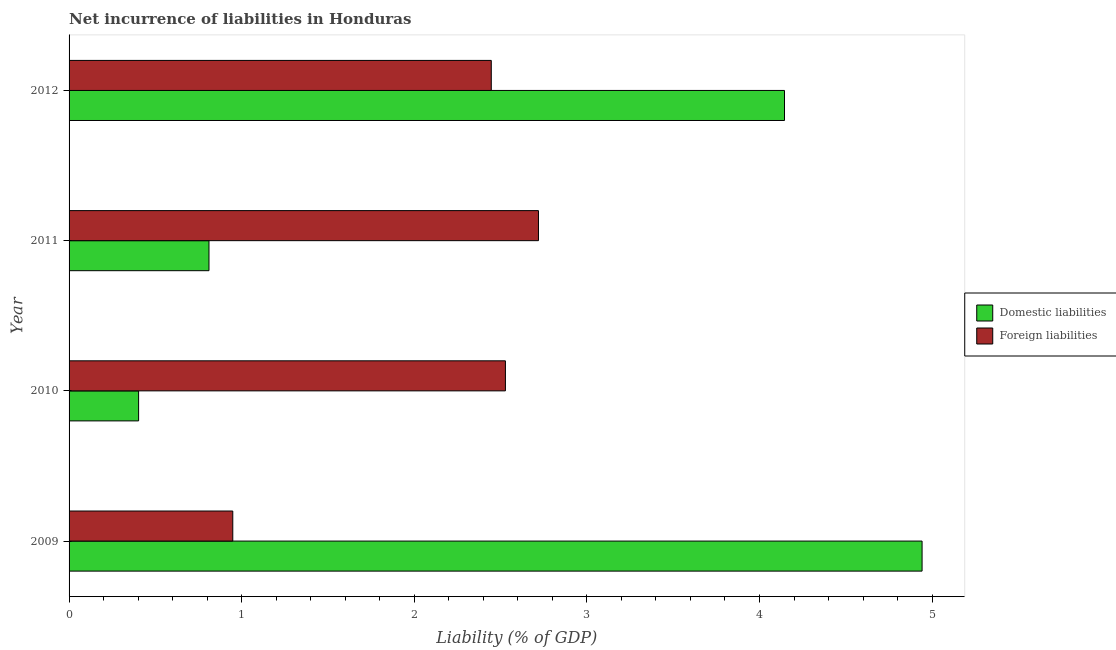How many different coloured bars are there?
Your answer should be very brief. 2. How many groups of bars are there?
Make the answer very short. 4. Are the number of bars per tick equal to the number of legend labels?
Give a very brief answer. Yes. Are the number of bars on each tick of the Y-axis equal?
Keep it short and to the point. Yes. How many bars are there on the 2nd tick from the top?
Your answer should be very brief. 2. How many bars are there on the 1st tick from the bottom?
Your answer should be compact. 2. In how many cases, is the number of bars for a given year not equal to the number of legend labels?
Keep it short and to the point. 0. What is the incurrence of foreign liabilities in 2010?
Provide a succinct answer. 2.53. Across all years, what is the maximum incurrence of foreign liabilities?
Offer a very short reply. 2.72. Across all years, what is the minimum incurrence of domestic liabilities?
Offer a very short reply. 0.4. In which year was the incurrence of domestic liabilities maximum?
Provide a short and direct response. 2009. What is the total incurrence of domestic liabilities in the graph?
Keep it short and to the point. 10.3. What is the difference between the incurrence of foreign liabilities in 2009 and that in 2011?
Make the answer very short. -1.77. What is the difference between the incurrence of foreign liabilities in 2009 and the incurrence of domestic liabilities in 2010?
Your answer should be very brief. 0.55. What is the average incurrence of foreign liabilities per year?
Make the answer very short. 2.16. In the year 2010, what is the difference between the incurrence of foreign liabilities and incurrence of domestic liabilities?
Your answer should be very brief. 2.12. In how many years, is the incurrence of foreign liabilities greater than 2.4 %?
Your answer should be very brief. 3. Is the incurrence of domestic liabilities in 2010 less than that in 2011?
Give a very brief answer. Yes. What is the difference between the highest and the second highest incurrence of domestic liabilities?
Offer a very short reply. 0.8. What is the difference between the highest and the lowest incurrence of foreign liabilities?
Make the answer very short. 1.77. Is the sum of the incurrence of foreign liabilities in 2010 and 2012 greater than the maximum incurrence of domestic liabilities across all years?
Provide a succinct answer. Yes. What does the 2nd bar from the top in 2012 represents?
Your response must be concise. Domestic liabilities. What does the 2nd bar from the bottom in 2011 represents?
Give a very brief answer. Foreign liabilities. How many bars are there?
Your response must be concise. 8. Are all the bars in the graph horizontal?
Make the answer very short. Yes. How many years are there in the graph?
Provide a short and direct response. 4. Are the values on the major ticks of X-axis written in scientific E-notation?
Your answer should be very brief. No. Where does the legend appear in the graph?
Give a very brief answer. Center right. How many legend labels are there?
Ensure brevity in your answer.  2. What is the title of the graph?
Your response must be concise. Net incurrence of liabilities in Honduras. Does "Urban" appear as one of the legend labels in the graph?
Your answer should be very brief. No. What is the label or title of the X-axis?
Offer a very short reply. Liability (% of GDP). What is the label or title of the Y-axis?
Make the answer very short. Year. What is the Liability (% of GDP) in Domestic liabilities in 2009?
Keep it short and to the point. 4.94. What is the Liability (% of GDP) in Foreign liabilities in 2009?
Make the answer very short. 0.95. What is the Liability (% of GDP) of Domestic liabilities in 2010?
Ensure brevity in your answer.  0.4. What is the Liability (% of GDP) in Foreign liabilities in 2010?
Give a very brief answer. 2.53. What is the Liability (% of GDP) in Domestic liabilities in 2011?
Your answer should be compact. 0.81. What is the Liability (% of GDP) of Foreign liabilities in 2011?
Make the answer very short. 2.72. What is the Liability (% of GDP) in Domestic liabilities in 2012?
Make the answer very short. 4.14. What is the Liability (% of GDP) in Foreign liabilities in 2012?
Your response must be concise. 2.45. Across all years, what is the maximum Liability (% of GDP) in Domestic liabilities?
Your answer should be compact. 4.94. Across all years, what is the maximum Liability (% of GDP) in Foreign liabilities?
Provide a succinct answer. 2.72. Across all years, what is the minimum Liability (% of GDP) of Domestic liabilities?
Ensure brevity in your answer.  0.4. Across all years, what is the minimum Liability (% of GDP) in Foreign liabilities?
Give a very brief answer. 0.95. What is the total Liability (% of GDP) in Domestic liabilities in the graph?
Keep it short and to the point. 10.3. What is the total Liability (% of GDP) of Foreign liabilities in the graph?
Your response must be concise. 8.64. What is the difference between the Liability (% of GDP) in Domestic liabilities in 2009 and that in 2010?
Offer a terse response. 4.54. What is the difference between the Liability (% of GDP) of Foreign liabilities in 2009 and that in 2010?
Your answer should be compact. -1.58. What is the difference between the Liability (% of GDP) of Domestic liabilities in 2009 and that in 2011?
Your answer should be compact. 4.13. What is the difference between the Liability (% of GDP) in Foreign liabilities in 2009 and that in 2011?
Provide a succinct answer. -1.77. What is the difference between the Liability (% of GDP) in Domestic liabilities in 2009 and that in 2012?
Your answer should be very brief. 0.8. What is the difference between the Liability (% of GDP) of Foreign liabilities in 2009 and that in 2012?
Your answer should be very brief. -1.5. What is the difference between the Liability (% of GDP) in Domestic liabilities in 2010 and that in 2011?
Offer a very short reply. -0.41. What is the difference between the Liability (% of GDP) in Foreign liabilities in 2010 and that in 2011?
Your answer should be compact. -0.19. What is the difference between the Liability (% of GDP) in Domestic liabilities in 2010 and that in 2012?
Keep it short and to the point. -3.74. What is the difference between the Liability (% of GDP) in Foreign liabilities in 2010 and that in 2012?
Provide a succinct answer. 0.08. What is the difference between the Liability (% of GDP) in Domestic liabilities in 2011 and that in 2012?
Provide a short and direct response. -3.33. What is the difference between the Liability (% of GDP) in Foreign liabilities in 2011 and that in 2012?
Your answer should be compact. 0.27. What is the difference between the Liability (% of GDP) of Domestic liabilities in 2009 and the Liability (% of GDP) of Foreign liabilities in 2010?
Give a very brief answer. 2.41. What is the difference between the Liability (% of GDP) in Domestic liabilities in 2009 and the Liability (% of GDP) in Foreign liabilities in 2011?
Offer a terse response. 2.22. What is the difference between the Liability (% of GDP) in Domestic liabilities in 2009 and the Liability (% of GDP) in Foreign liabilities in 2012?
Offer a very short reply. 2.5. What is the difference between the Liability (% of GDP) of Domestic liabilities in 2010 and the Liability (% of GDP) of Foreign liabilities in 2011?
Provide a succinct answer. -2.32. What is the difference between the Liability (% of GDP) of Domestic liabilities in 2010 and the Liability (% of GDP) of Foreign liabilities in 2012?
Offer a terse response. -2.04. What is the difference between the Liability (% of GDP) in Domestic liabilities in 2011 and the Liability (% of GDP) in Foreign liabilities in 2012?
Ensure brevity in your answer.  -1.64. What is the average Liability (% of GDP) in Domestic liabilities per year?
Make the answer very short. 2.58. What is the average Liability (% of GDP) in Foreign liabilities per year?
Make the answer very short. 2.16. In the year 2009, what is the difference between the Liability (% of GDP) of Domestic liabilities and Liability (% of GDP) of Foreign liabilities?
Your answer should be compact. 3.99. In the year 2010, what is the difference between the Liability (% of GDP) of Domestic liabilities and Liability (% of GDP) of Foreign liabilities?
Offer a very short reply. -2.13. In the year 2011, what is the difference between the Liability (% of GDP) of Domestic liabilities and Liability (% of GDP) of Foreign liabilities?
Your answer should be compact. -1.91. In the year 2012, what is the difference between the Liability (% of GDP) in Domestic liabilities and Liability (% of GDP) in Foreign liabilities?
Make the answer very short. 1.7. What is the ratio of the Liability (% of GDP) in Domestic liabilities in 2009 to that in 2010?
Make the answer very short. 12.27. What is the ratio of the Liability (% of GDP) of Foreign liabilities in 2009 to that in 2010?
Ensure brevity in your answer.  0.38. What is the ratio of the Liability (% of GDP) in Domestic liabilities in 2009 to that in 2011?
Make the answer very short. 6.1. What is the ratio of the Liability (% of GDP) in Foreign liabilities in 2009 to that in 2011?
Provide a short and direct response. 0.35. What is the ratio of the Liability (% of GDP) in Domestic liabilities in 2009 to that in 2012?
Give a very brief answer. 1.19. What is the ratio of the Liability (% of GDP) in Foreign liabilities in 2009 to that in 2012?
Provide a succinct answer. 0.39. What is the ratio of the Liability (% of GDP) of Domestic liabilities in 2010 to that in 2011?
Your response must be concise. 0.5. What is the ratio of the Liability (% of GDP) of Foreign liabilities in 2010 to that in 2011?
Make the answer very short. 0.93. What is the ratio of the Liability (% of GDP) in Domestic liabilities in 2010 to that in 2012?
Offer a terse response. 0.1. What is the ratio of the Liability (% of GDP) of Foreign liabilities in 2010 to that in 2012?
Your answer should be very brief. 1.03. What is the ratio of the Liability (% of GDP) of Domestic liabilities in 2011 to that in 2012?
Your answer should be compact. 0.2. What is the ratio of the Liability (% of GDP) of Foreign liabilities in 2011 to that in 2012?
Your answer should be very brief. 1.11. What is the difference between the highest and the second highest Liability (% of GDP) in Domestic liabilities?
Your answer should be very brief. 0.8. What is the difference between the highest and the second highest Liability (% of GDP) of Foreign liabilities?
Offer a terse response. 0.19. What is the difference between the highest and the lowest Liability (% of GDP) in Domestic liabilities?
Your response must be concise. 4.54. What is the difference between the highest and the lowest Liability (% of GDP) in Foreign liabilities?
Make the answer very short. 1.77. 